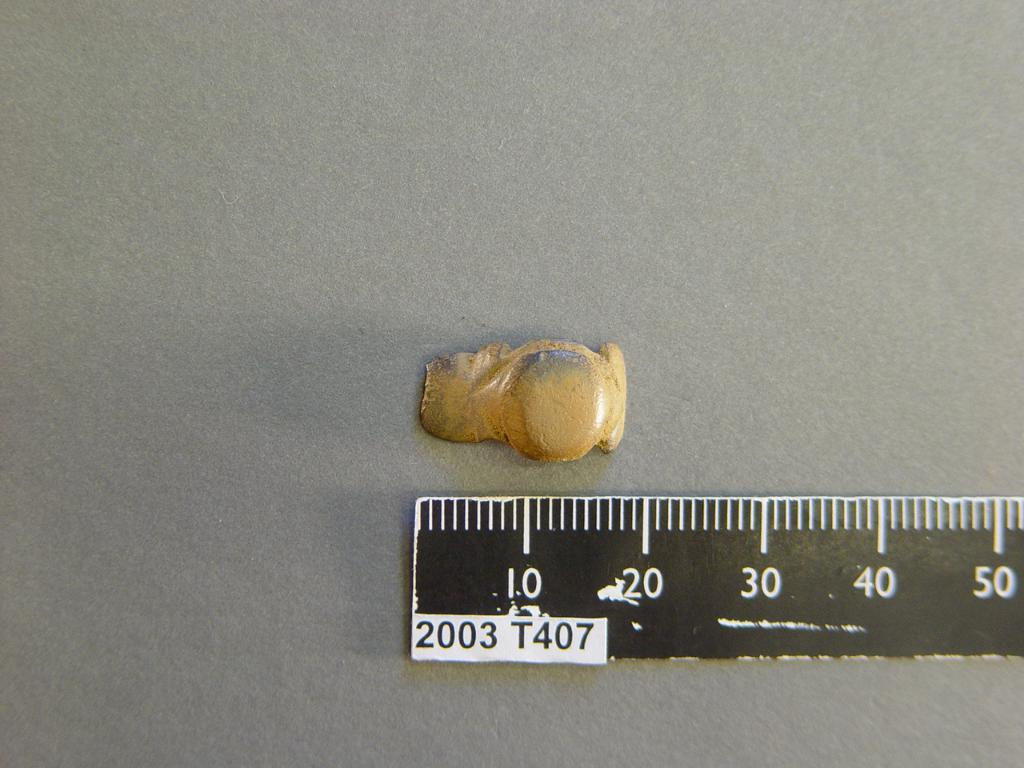Provide a one-sentence caption for the provided image. A ruler with the number 2003 on it is next to a piece of puddy. 